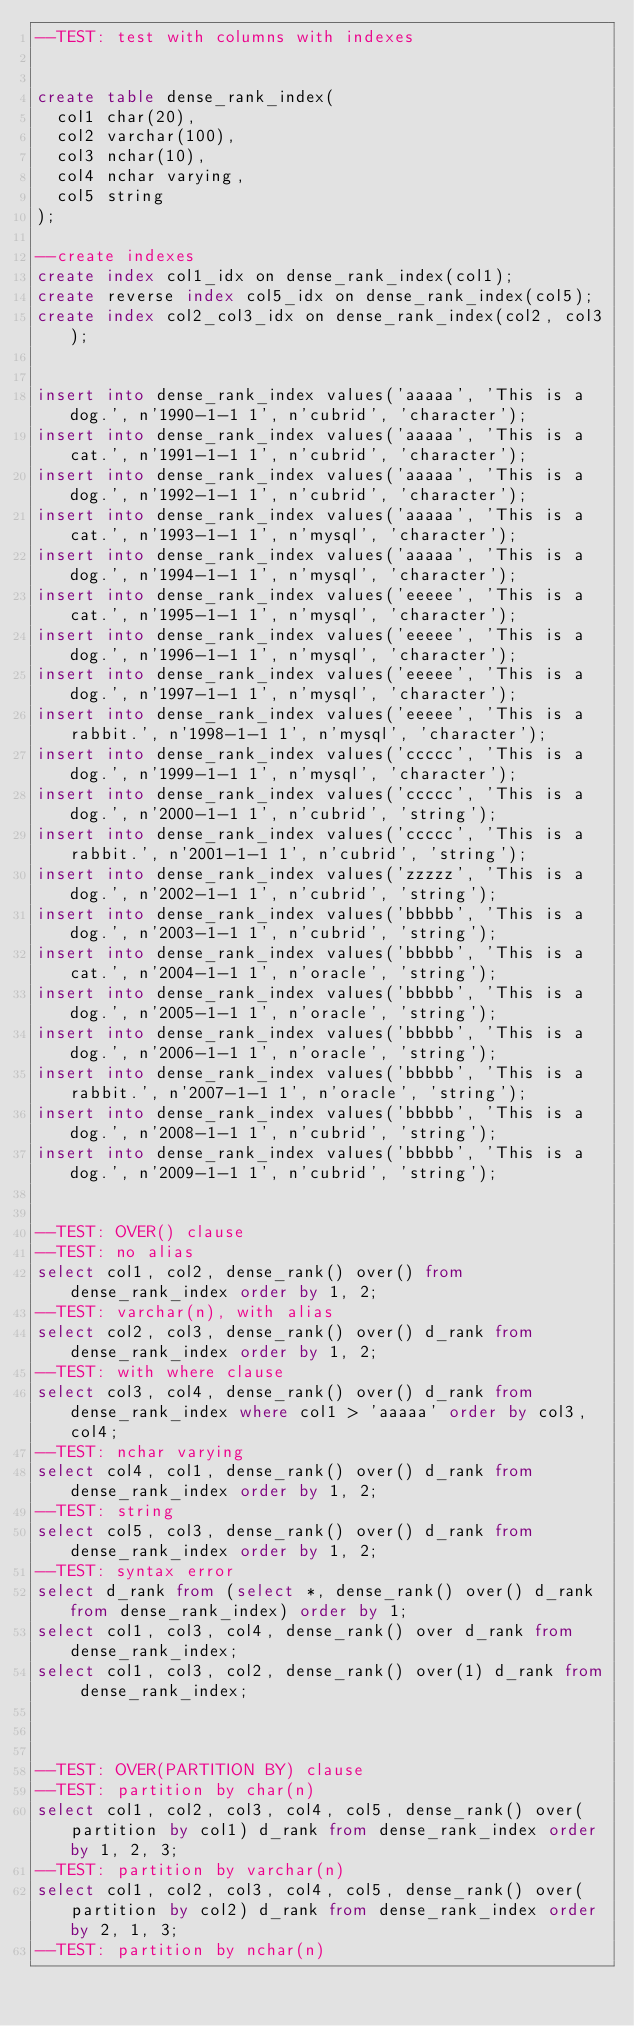Convert code to text. <code><loc_0><loc_0><loc_500><loc_500><_SQL_>--TEST: test with columns with indexes 


create table dense_rank_index(
	col1 char(20),
	col2 varchar(100), 
	col3 nchar(10),
	col4 nchar varying,
	col5 string
);

--create indexes
create index col1_idx on dense_rank_index(col1);
create reverse index col5_idx on dense_rank_index(col5);
create index col2_col3_idx on dense_rank_index(col2, col3);


insert into dense_rank_index values('aaaaa', 'This is a dog.', n'1990-1-1 1', n'cubrid', 'character');
insert into dense_rank_index values('aaaaa', 'This is a cat.', n'1991-1-1 1', n'cubrid', 'character');
insert into dense_rank_index values('aaaaa', 'This is a dog.', n'1992-1-1 1', n'cubrid', 'character');
insert into dense_rank_index values('aaaaa', 'This is a cat.', n'1993-1-1 1', n'mysql', 'character');
insert into dense_rank_index values('aaaaa', 'This is a dog.', n'1994-1-1 1', n'mysql', 'character');
insert into dense_rank_index values('eeeee', 'This is a cat.', n'1995-1-1 1', n'mysql', 'character');
insert into dense_rank_index values('eeeee', 'This is a dog.', n'1996-1-1 1', n'mysql', 'character');
insert into dense_rank_index values('eeeee', 'This is a dog.', n'1997-1-1 1', n'mysql', 'character');
insert into dense_rank_index values('eeeee', 'This is a rabbit.', n'1998-1-1 1', n'mysql', 'character');
insert into dense_rank_index values('ccccc', 'This is a dog.', n'1999-1-1 1', n'mysql', 'character');
insert into dense_rank_index values('ccccc', 'This is a dog.', n'2000-1-1 1', n'cubrid', 'string');
insert into dense_rank_index values('ccccc', 'This is a rabbit.', n'2001-1-1 1', n'cubrid', 'string');
insert into dense_rank_index values('zzzzz', 'This is a dog.', n'2002-1-1 1', n'cubrid', 'string');
insert into dense_rank_index values('bbbbb', 'This is a dog.', n'2003-1-1 1', n'cubrid', 'string');
insert into dense_rank_index values('bbbbb', 'This is a cat.', n'2004-1-1 1', n'oracle', 'string');
insert into dense_rank_index values('bbbbb', 'This is a dog.', n'2005-1-1 1', n'oracle', 'string');
insert into dense_rank_index values('bbbbb', 'This is a dog.', n'2006-1-1 1', n'oracle', 'string');
insert into dense_rank_index values('bbbbb', 'This is a rabbit.', n'2007-1-1 1', n'oracle', 'string');
insert into dense_rank_index values('bbbbb', 'This is a dog.', n'2008-1-1 1', n'cubrid', 'string');
insert into dense_rank_index values('bbbbb', 'This is a dog.', n'2009-1-1 1', n'cubrid', 'string');


--TEST: OVER() clause
--TEST: no alias
select col1, col2, dense_rank() over() from dense_rank_index order by 1, 2;
--TEST: varchar(n), with alias
select col2, col3, dense_rank() over() d_rank from dense_rank_index order by 1, 2;
--TEST: with where clause
select col3, col4, dense_rank() over() d_rank from dense_rank_index where col1 > 'aaaaa' order by col3, col4;
--TEST: nchar varying
select col4, col1, dense_rank() over() d_rank from dense_rank_index order by 1, 2;
--TEST: string
select col5, col3, dense_rank() over() d_rank from dense_rank_index order by 1, 2;
--TEST: syntax error
select d_rank from (select *, dense_rank() over() d_rank from dense_rank_index) order by 1;
select col1, col3, col4, dense_rank() over d_rank from dense_rank_index;
select col1, col3, col2, dense_rank() over(1) d_rank from dense_rank_index;



--TEST: OVER(PARTITION BY) clause
--TEST: partition by char(n)
select col1, col2, col3, col4, col5, dense_rank() over(partition by col1) d_rank from dense_rank_index order by 1, 2, 3;
--TEST: partition by varchar(n)
select col1, col2, col3, col4, col5, dense_rank() over(partition by col2) d_rank from dense_rank_index order by 2, 1, 3;
--TEST: partition by nchar(n)</code> 